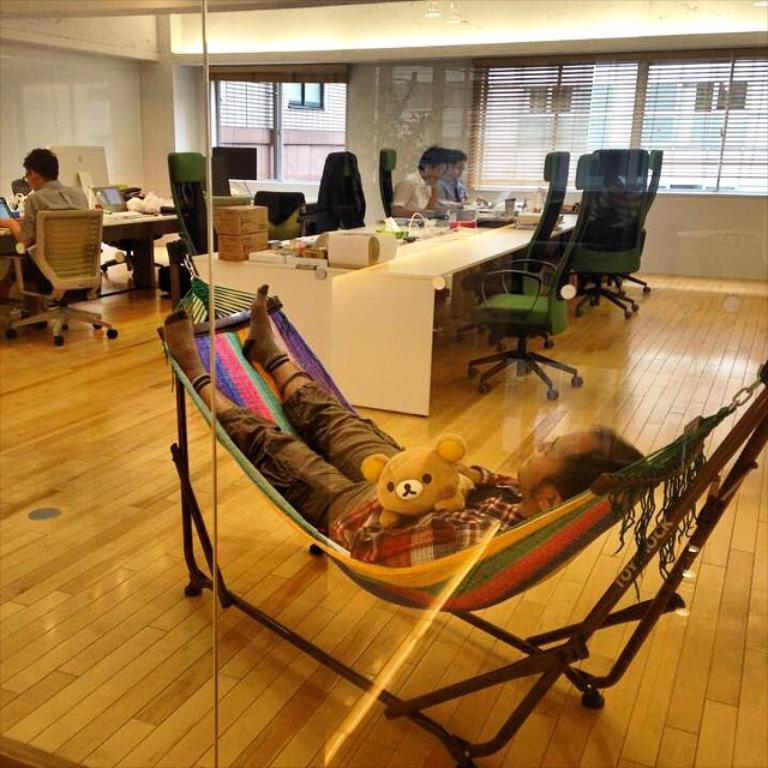What are the people in the image doing? The people in the image are seated on chairs. What objects can be seen on the table in the image? There are monitors, boxes, and papers on the table in the image. What is the position of the man in the image? The man is laying on a chair in the image. What is the man holding in his hand? The man is holding a toy in his hand. What type of crate is being used to store the papers in the image? There is no crate present in the image; the papers are on the table. What is the man learning from the tray in the image? There is no tray present in the image, and the man is holding a toy, not learning from anything. 